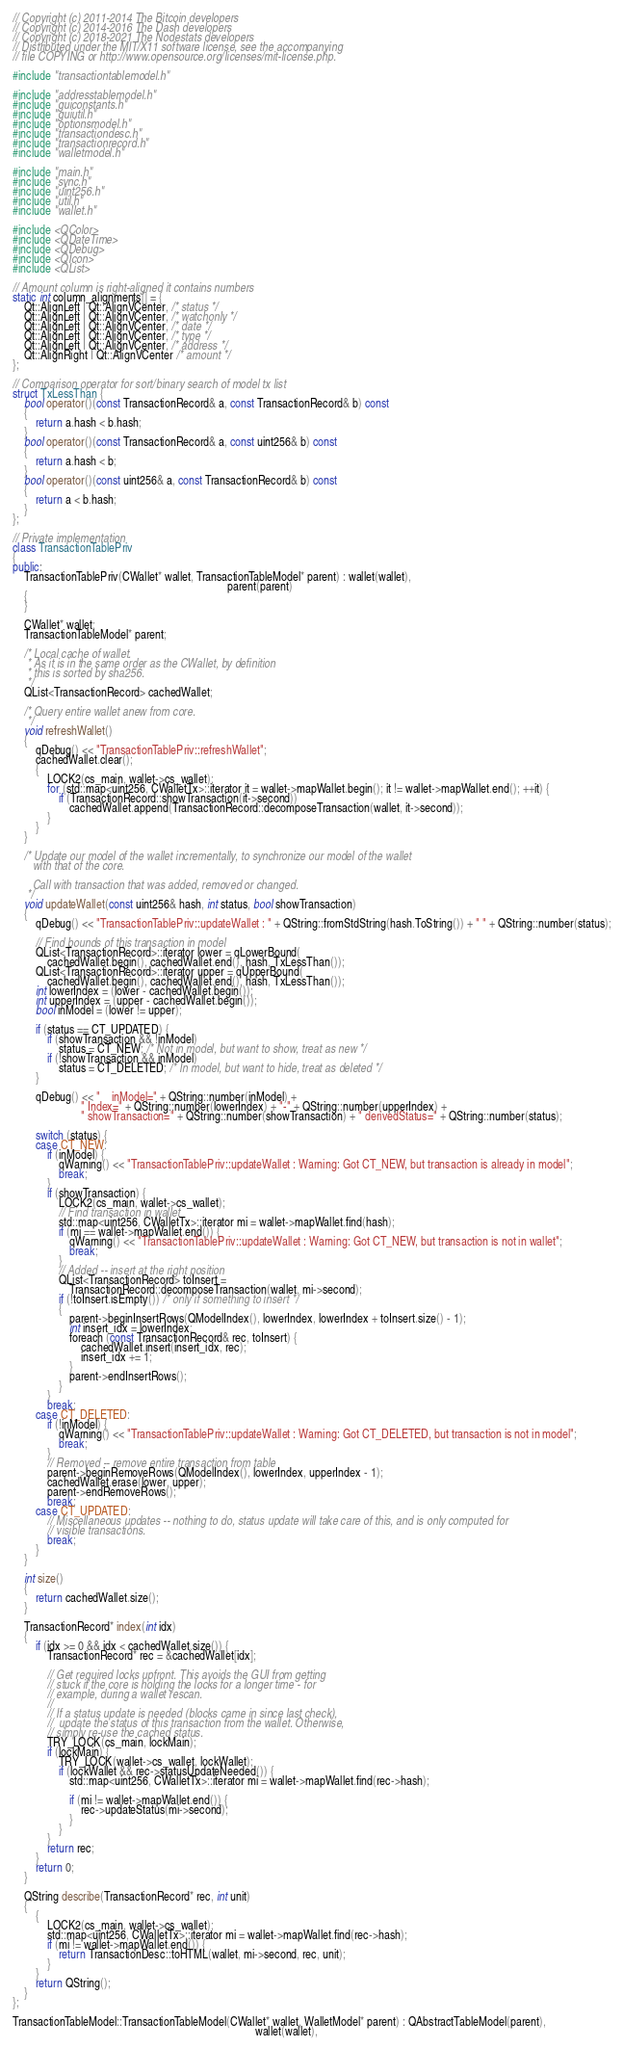Convert code to text. <code><loc_0><loc_0><loc_500><loc_500><_C++_>// Copyright (c) 2011-2014 The Bitcoin developers
// Copyright (c) 2014-2016 The Dash developers
// Copyright (c) 2018-2021 The Nodestats developers
// Distributed under the MIT/X11 software license, see the accompanying
// file COPYING or http://www.opensource.org/licenses/mit-license.php.

#include "transactiontablemodel.h"

#include "addresstablemodel.h"
#include "guiconstants.h"
#include "guiutil.h"
#include "optionsmodel.h"
#include "transactiondesc.h"
#include "transactionrecord.h"
#include "walletmodel.h"

#include "main.h"
#include "sync.h"
#include "uint256.h"
#include "util.h"
#include "wallet.h"

#include <QColor>
#include <QDateTime>
#include <QDebug>
#include <QIcon>
#include <QList>

// Amount column is right-aligned it contains numbers
static int column_alignments[] = {
    Qt::AlignLeft | Qt::AlignVCenter, /* status */
    Qt::AlignLeft | Qt::AlignVCenter, /* watchonly */
    Qt::AlignLeft | Qt::AlignVCenter, /* date */
    Qt::AlignLeft | Qt::AlignVCenter, /* type */
    Qt::AlignLeft | Qt::AlignVCenter, /* address */
    Qt::AlignRight | Qt::AlignVCenter /* amount */
};

// Comparison operator for sort/binary search of model tx list
struct TxLessThan {
    bool operator()(const TransactionRecord& a, const TransactionRecord& b) const
    {
        return a.hash < b.hash;
    }
    bool operator()(const TransactionRecord& a, const uint256& b) const
    {
        return a.hash < b;
    }
    bool operator()(const uint256& a, const TransactionRecord& b) const
    {
        return a < b.hash;
    }
};

// Private implementation
class TransactionTablePriv
{
public:
    TransactionTablePriv(CWallet* wallet, TransactionTableModel* parent) : wallet(wallet),
                                                                           parent(parent)
    {
    }

    CWallet* wallet;
    TransactionTableModel* parent;

    /* Local cache of wallet.
     * As it is in the same order as the CWallet, by definition
     * this is sorted by sha256.
     */
    QList<TransactionRecord> cachedWallet;

    /* Query entire wallet anew from core.
     */
    void refreshWallet()
    {
        qDebug() << "TransactionTablePriv::refreshWallet";
        cachedWallet.clear();
        {
            LOCK2(cs_main, wallet->cs_wallet);
            for (std::map<uint256, CWalletTx>::iterator it = wallet->mapWallet.begin(); it != wallet->mapWallet.end(); ++it) {
                if (TransactionRecord::showTransaction(it->second))
                    cachedWallet.append(TransactionRecord::decomposeTransaction(wallet, it->second));
            }
        }
    }

    /* Update our model of the wallet incrementally, to synchronize our model of the wallet
       with that of the core.

       Call with transaction that was added, removed or changed.
     */
    void updateWallet(const uint256& hash, int status, bool showTransaction)
    {
        qDebug() << "TransactionTablePriv::updateWallet : " + QString::fromStdString(hash.ToString()) + " " + QString::number(status);

        // Find bounds of this transaction in model
        QList<TransactionRecord>::iterator lower = qLowerBound(
            cachedWallet.begin(), cachedWallet.end(), hash, TxLessThan());
        QList<TransactionRecord>::iterator upper = qUpperBound(
            cachedWallet.begin(), cachedWallet.end(), hash, TxLessThan());
        int lowerIndex = (lower - cachedWallet.begin());
        int upperIndex = (upper - cachedWallet.begin());
        bool inModel = (lower != upper);

        if (status == CT_UPDATED) {
            if (showTransaction && !inModel)
                status = CT_NEW; /* Not in model, but want to show, treat as new */
            if (!showTransaction && inModel)
                status = CT_DELETED; /* In model, but want to hide, treat as deleted */
        }

        qDebug() << "    inModel=" + QString::number(inModel) +
                        " Index=" + QString::number(lowerIndex) + "-" + QString::number(upperIndex) +
                        " showTransaction=" + QString::number(showTransaction) + " derivedStatus=" + QString::number(status);

        switch (status) {
        case CT_NEW:
            if (inModel) {
                qWarning() << "TransactionTablePriv::updateWallet : Warning: Got CT_NEW, but transaction is already in model";
                break;
            }
            if (showTransaction) {
                LOCK2(cs_main, wallet->cs_wallet);
                // Find transaction in wallet
                std::map<uint256, CWalletTx>::iterator mi = wallet->mapWallet.find(hash);
                if (mi == wallet->mapWallet.end()) {
                    qWarning() << "TransactionTablePriv::updateWallet : Warning: Got CT_NEW, but transaction is not in wallet";
                    break;
                }
                // Added -- insert at the right position
                QList<TransactionRecord> toInsert =
                    TransactionRecord::decomposeTransaction(wallet, mi->second);
                if (!toInsert.isEmpty()) /* only if something to insert */
                {
                    parent->beginInsertRows(QModelIndex(), lowerIndex, lowerIndex + toInsert.size() - 1);
                    int insert_idx = lowerIndex;
                    foreach (const TransactionRecord& rec, toInsert) {
                        cachedWallet.insert(insert_idx, rec);
                        insert_idx += 1;
                    }
                    parent->endInsertRows();
                }
            }
            break;
        case CT_DELETED:
            if (!inModel) {
                qWarning() << "TransactionTablePriv::updateWallet : Warning: Got CT_DELETED, but transaction is not in model";
                break;
            }
            // Removed -- remove entire transaction from table
            parent->beginRemoveRows(QModelIndex(), lowerIndex, upperIndex - 1);
            cachedWallet.erase(lower, upper);
            parent->endRemoveRows();
            break;
        case CT_UPDATED:
            // Miscellaneous updates -- nothing to do, status update will take care of this, and is only computed for
            // visible transactions.
            break;
        }
    }

    int size()
    {
        return cachedWallet.size();
    }

    TransactionRecord* index(int idx)
    {
        if (idx >= 0 && idx < cachedWallet.size()) {
            TransactionRecord* rec = &cachedWallet[idx];

            // Get required locks upfront. This avoids the GUI from getting
            // stuck if the core is holding the locks for a longer time - for
            // example, during a wallet rescan.
            //
            // If a status update is needed (blocks came in since last check),
            //  update the status of this transaction from the wallet. Otherwise,
            // simply re-use the cached status.
            TRY_LOCK(cs_main, lockMain);
            if (lockMain) {
                TRY_LOCK(wallet->cs_wallet, lockWallet);
                if (lockWallet && rec->statusUpdateNeeded()) {
                    std::map<uint256, CWalletTx>::iterator mi = wallet->mapWallet.find(rec->hash);

                    if (mi != wallet->mapWallet.end()) {
                        rec->updateStatus(mi->second);
                    }
                }
            }
            return rec;
        }
        return 0;
    }

    QString describe(TransactionRecord* rec, int unit)
    {
        {
            LOCK2(cs_main, wallet->cs_wallet);
            std::map<uint256, CWalletTx>::iterator mi = wallet->mapWallet.find(rec->hash);
            if (mi != wallet->mapWallet.end()) {
                return TransactionDesc::toHTML(wallet, mi->second, rec, unit);
            }
        }
        return QString();
    }
};

TransactionTableModel::TransactionTableModel(CWallet* wallet, WalletModel* parent) : QAbstractTableModel(parent),
                                                                                     wallet(wallet),</code> 